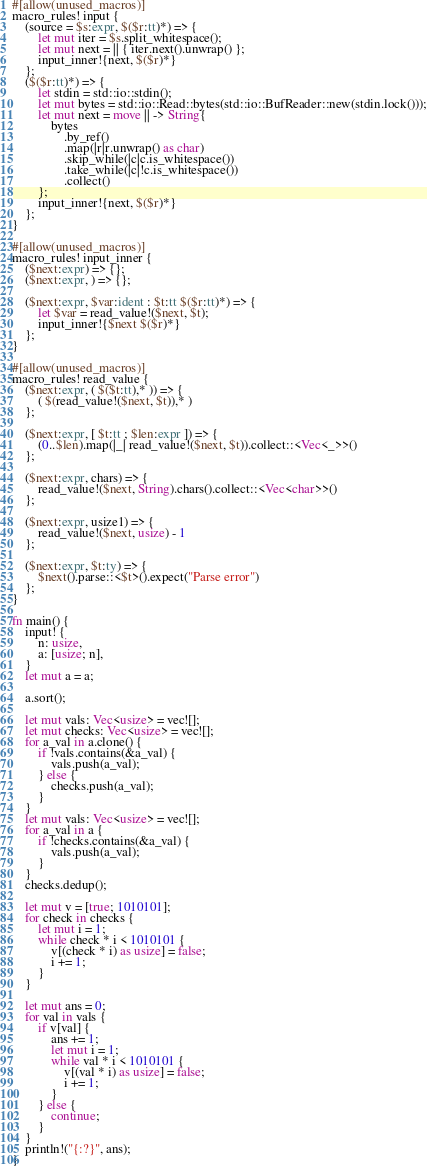Convert code to text. <code><loc_0><loc_0><loc_500><loc_500><_Rust_>#[allow(unused_macros)]
macro_rules! input {
    (source = $s:expr, $($r:tt)*) => {
        let mut iter = $s.split_whitespace();
        let mut next = || { iter.next().unwrap() };
        input_inner!{next, $($r)*}
    };
    ($($r:tt)*) => {
        let stdin = std::io::stdin();
        let mut bytes = std::io::Read::bytes(std::io::BufReader::new(stdin.lock()));
        let mut next = move || -> String{
            bytes
                .by_ref()
                .map(|r|r.unwrap() as char)
                .skip_while(|c|c.is_whitespace())
                .take_while(|c|!c.is_whitespace())
                .collect()
        };
        input_inner!{next, $($r)*}
    };
}

#[allow(unused_macros)]
macro_rules! input_inner {
    ($next:expr) => {};
    ($next:expr, ) => {};

    ($next:expr, $var:ident : $t:tt $($r:tt)*) => {
        let $var = read_value!($next, $t);
        input_inner!{$next $($r)*}
    };
}

#[allow(unused_macros)]
macro_rules! read_value {
    ($next:expr, ( $($t:tt),* )) => {
        ( $(read_value!($next, $t)),* )
    };

    ($next:expr, [ $t:tt ; $len:expr ]) => {
        (0..$len).map(|_| read_value!($next, $t)).collect::<Vec<_>>()
    };

    ($next:expr, chars) => {
        read_value!($next, String).chars().collect::<Vec<char>>()
    };

    ($next:expr, usize1) => {
        read_value!($next, usize) - 1
    };

    ($next:expr, $t:ty) => {
        $next().parse::<$t>().expect("Parse error")
    };
}

fn main() {
    input! {
        n: usize,
        a: [usize; n],
    }
    let mut a = a;

    a.sort();

    let mut vals: Vec<usize> = vec![];
    let mut checks: Vec<usize> = vec![];
    for a_val in a.clone() {
        if !vals.contains(&a_val) {
            vals.push(a_val);
        } else {
            checks.push(a_val);
        }
    }
    let mut vals: Vec<usize> = vec![];
    for a_val in a {
        if !checks.contains(&a_val) {
            vals.push(a_val);
        }
    }
    checks.dedup();

    let mut v = [true; 1010101];
    for check in checks {
        let mut i = 1;
        while check * i < 1010101 {
            v[(check * i) as usize] = false;
            i += 1;
        }
    }

    let mut ans = 0;
    for val in vals {
        if v[val] {
            ans += 1;
            let mut i = 1;
            while val * i < 1010101 {
                v[(val * i) as usize] = false;
                i += 1;
            }
        } else {
            continue;
        }
    }
    println!("{:?}", ans);
}
</code> 